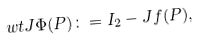<formula> <loc_0><loc_0><loc_500><loc_500>\ w t J \Phi ( P ) \colon = I _ { 2 } - J f ( P ) ,</formula> 